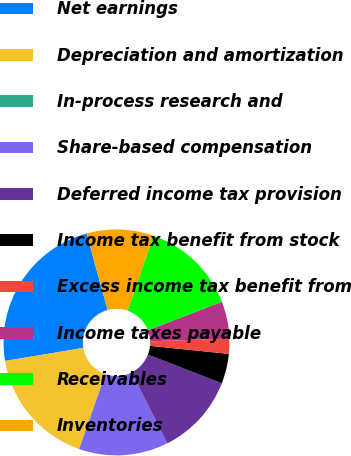<chart> <loc_0><loc_0><loc_500><loc_500><pie_chart><fcel>Net earnings<fcel>Depreciation and amortization<fcel>In-process research and<fcel>Share-based compensation<fcel>Deferred income tax provision<fcel>Income tax benefit from stock<fcel>Excess income tax benefit from<fcel>Income taxes payable<fcel>Receivables<fcel>Inventories<nl><fcel>23.36%<fcel>17.0%<fcel>0.03%<fcel>12.76%<fcel>11.7%<fcel>4.27%<fcel>2.15%<fcel>5.33%<fcel>13.82%<fcel>9.58%<nl></chart> 